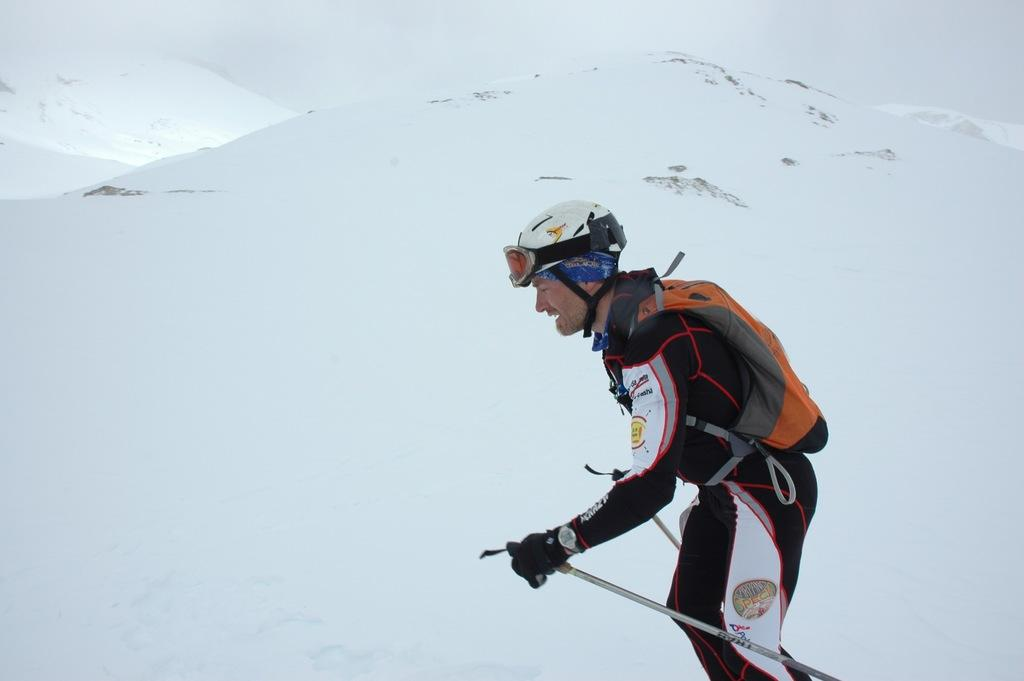What is the man doing in the image? The man is skiing in the snow. On which side of the image is the man located? The man is on the right side of the image. What color is the dress the man is wearing? The man is wearing a black color dress. What color is the bag the man is carrying? The man has an orange color bag. What type of beam is holding up the stage in the image? There is no stage or beam present in the image; it features a man skiing in the snow. How many matches are visible in the image? There are no matches visible in the image. 